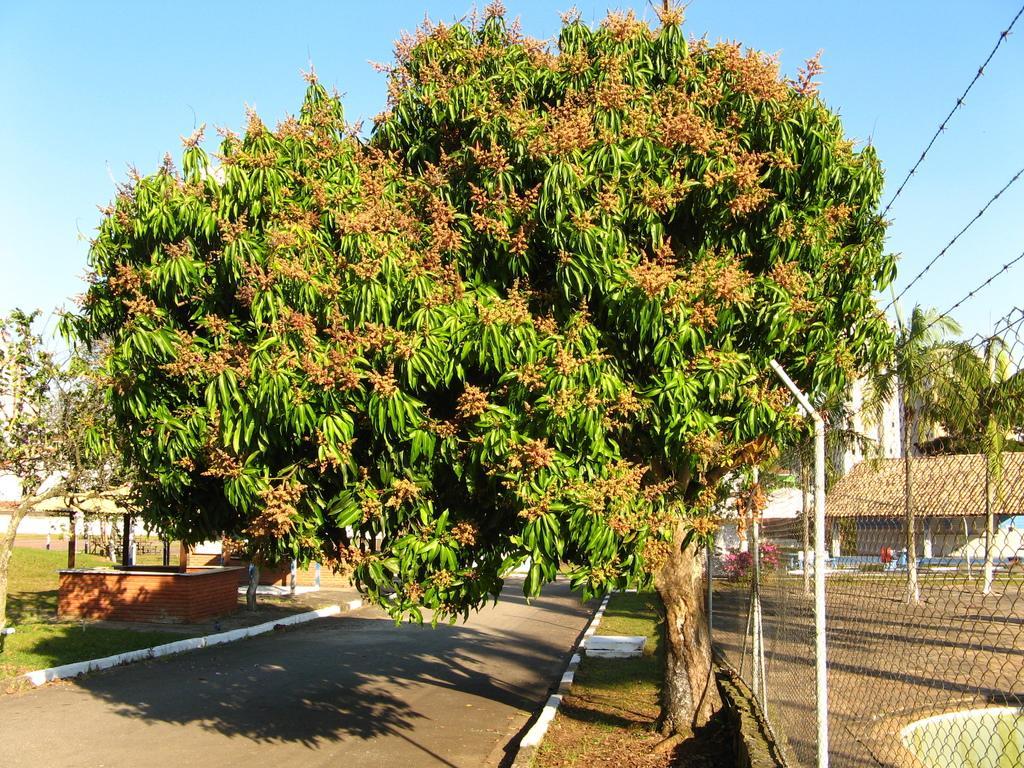In one or two sentences, can you explain what this image depicts? In the foreground of this picture, there is a tree on the side path to the road. On the right, there is fencing and in the background, there are houses, trees and the sky. On the left, there is a shed, trees and the grass. On the top, we can see the sky. 